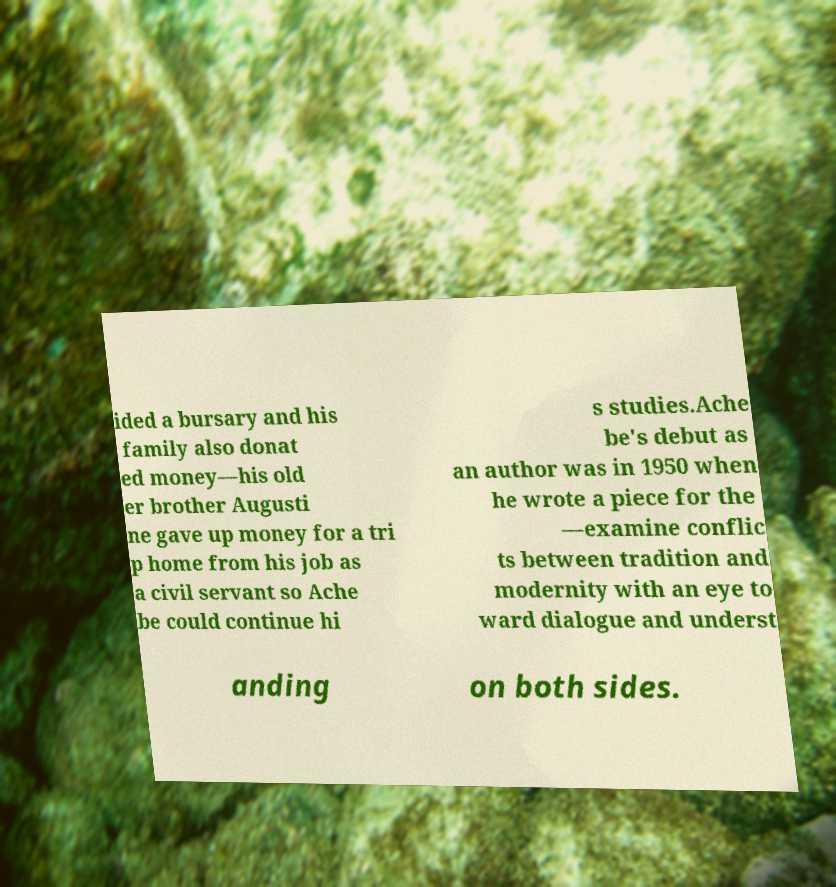There's text embedded in this image that I need extracted. Can you transcribe it verbatim? ided a bursary and his family also donat ed money—his old er brother Augusti ne gave up money for a tri p home from his job as a civil servant so Ache be could continue hi s studies.Ache be's debut as an author was in 1950 when he wrote a piece for the —examine conflic ts between tradition and modernity with an eye to ward dialogue and underst anding on both sides. 